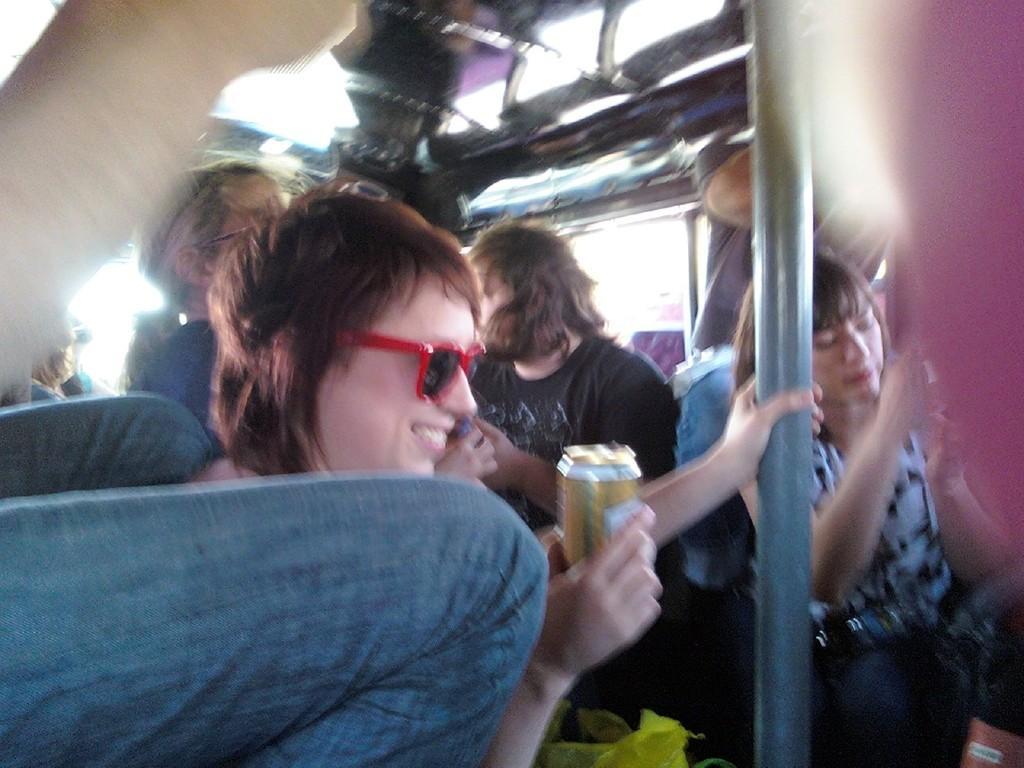Could you give a brief overview of what you see in this image? This image is slightly blurred, where we can see this person wearing glasses and holding a tin in hands and smiling, also we can see a few more people and a pole here. 